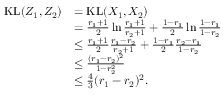<formula> <loc_0><loc_0><loc_500><loc_500>\begin{array} { r l } { K L ( Z _ { 1 } , Z _ { 2 } ) } & { = K L ( X _ { 1 } , X _ { 2 } ) } \\ & { = \frac { r _ { 1 } + 1 } { 2 } \ln \frac { r _ { 1 } + 1 } { r _ { 2 } + 1 } + \frac { 1 - r _ { 1 } } { 2 } \ln \frac { 1 - r _ { 1 } } { 1 - r _ { 2 } } } \\ & { \leq \frac { r _ { 1 } + 1 } { 2 } \frac { r _ { 1 } - r _ { 2 } } { r _ { 2 } + 1 } + \frac { 1 - r _ { 1 } } { 2 } \frac { r _ { 2 } - r _ { 1 } } { 1 - r _ { 2 } } } \\ & { \leq \frac { ( r _ { 1 } - r _ { 2 } ) ^ { 2 } } { 1 - r _ { 2 } ^ { 2 } } } \\ & { \leq \frac { 4 } { 3 } ( r _ { 1 } - r _ { 2 } ) ^ { 2 } . } \end{array}</formula> 